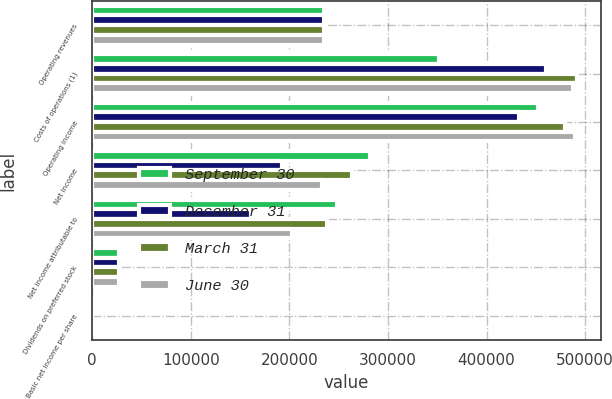<chart> <loc_0><loc_0><loc_500><loc_500><stacked_bar_chart><ecel><fcel>Operating revenues<fcel>Costs of operations (1)<fcel>Operating income<fcel>Net income<fcel>Net income attributable to<fcel>Dividends on preferred stock<fcel>Basic net income per share<nl><fcel>September 30<fcel>235290<fcel>351445<fcel>451853<fcel>281307<fcel>248378<fcel>26781<fcel>0.59<nl><fcel>December 31<fcel>235290<fcel>459711<fcel>432806<fcel>192464<fcel>160768<fcel>26782<fcel>0.38<nl><fcel>March 31<fcel>235290<fcel>491237<fcel>479074<fcel>263735<fcel>237728<fcel>26781<fcel>0.56<nl><fcel>June 30<fcel>235290<fcel>487996<fcel>489296<fcel>232853<fcel>202426<fcel>26781<fcel>0.48<nl></chart> 